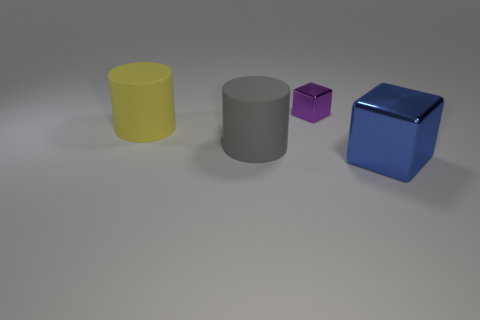Add 2 tiny purple things. How many objects exist? 6 Subtract all red cubes. Subtract all red balls. How many cubes are left? 2 Subtract all purple blocks. How many blue cylinders are left? 0 Subtract all metallic blocks. Subtract all metallic things. How many objects are left? 0 Add 4 large yellow cylinders. How many large yellow cylinders are left? 5 Add 1 brown matte cylinders. How many brown matte cylinders exist? 1 Subtract 0 brown spheres. How many objects are left? 4 